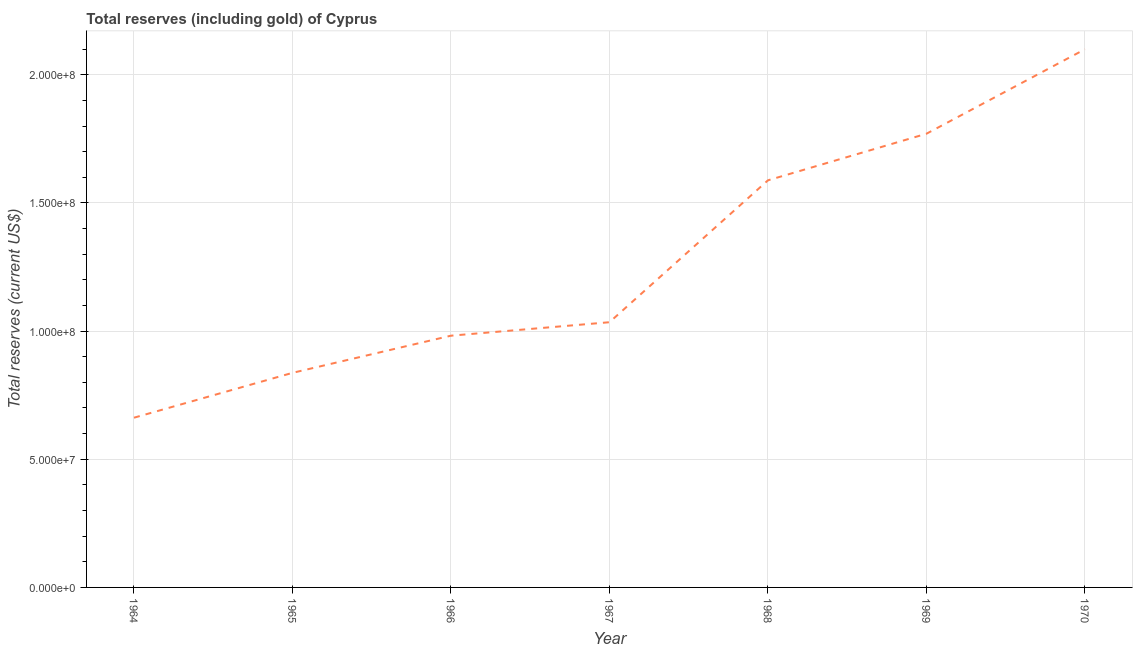What is the total reserves (including gold) in 1969?
Give a very brief answer. 1.77e+08. Across all years, what is the maximum total reserves (including gold)?
Your answer should be very brief. 2.10e+08. Across all years, what is the minimum total reserves (including gold)?
Give a very brief answer. 6.62e+07. In which year was the total reserves (including gold) minimum?
Your answer should be very brief. 1964. What is the sum of the total reserves (including gold)?
Make the answer very short. 8.97e+08. What is the difference between the total reserves (including gold) in 1966 and 1970?
Your answer should be compact. -1.12e+08. What is the average total reserves (including gold) per year?
Ensure brevity in your answer.  1.28e+08. What is the median total reserves (including gold)?
Your answer should be very brief. 1.03e+08. In how many years, is the total reserves (including gold) greater than 40000000 US$?
Your answer should be very brief. 7. What is the ratio of the total reserves (including gold) in 1966 to that in 1970?
Offer a terse response. 0.47. What is the difference between the highest and the second highest total reserves (including gold)?
Ensure brevity in your answer.  3.30e+07. What is the difference between the highest and the lowest total reserves (including gold)?
Your answer should be very brief. 1.44e+08. In how many years, is the total reserves (including gold) greater than the average total reserves (including gold) taken over all years?
Your response must be concise. 3. Does the total reserves (including gold) monotonically increase over the years?
Your response must be concise. Yes. How many lines are there?
Your answer should be very brief. 1. How many years are there in the graph?
Your response must be concise. 7. Are the values on the major ticks of Y-axis written in scientific E-notation?
Provide a succinct answer. Yes. What is the title of the graph?
Provide a succinct answer. Total reserves (including gold) of Cyprus. What is the label or title of the X-axis?
Your response must be concise. Year. What is the label or title of the Y-axis?
Provide a short and direct response. Total reserves (current US$). What is the Total reserves (current US$) in 1964?
Provide a succinct answer. 6.62e+07. What is the Total reserves (current US$) in 1965?
Ensure brevity in your answer.  8.37e+07. What is the Total reserves (current US$) of 1966?
Give a very brief answer. 9.82e+07. What is the Total reserves (current US$) in 1967?
Offer a terse response. 1.03e+08. What is the Total reserves (current US$) in 1968?
Your answer should be compact. 1.59e+08. What is the Total reserves (current US$) of 1969?
Offer a very short reply. 1.77e+08. What is the Total reserves (current US$) of 1970?
Your answer should be very brief. 2.10e+08. What is the difference between the Total reserves (current US$) in 1964 and 1965?
Provide a succinct answer. -1.75e+07. What is the difference between the Total reserves (current US$) in 1964 and 1966?
Offer a very short reply. -3.20e+07. What is the difference between the Total reserves (current US$) in 1964 and 1967?
Your answer should be compact. -3.72e+07. What is the difference between the Total reserves (current US$) in 1964 and 1968?
Give a very brief answer. -9.26e+07. What is the difference between the Total reserves (current US$) in 1964 and 1969?
Give a very brief answer. -1.11e+08. What is the difference between the Total reserves (current US$) in 1964 and 1970?
Give a very brief answer. -1.44e+08. What is the difference between the Total reserves (current US$) in 1965 and 1966?
Offer a terse response. -1.45e+07. What is the difference between the Total reserves (current US$) in 1965 and 1967?
Provide a succinct answer. -1.97e+07. What is the difference between the Total reserves (current US$) in 1965 and 1968?
Make the answer very short. -7.51e+07. What is the difference between the Total reserves (current US$) in 1965 and 1969?
Give a very brief answer. -9.33e+07. What is the difference between the Total reserves (current US$) in 1965 and 1970?
Give a very brief answer. -1.26e+08. What is the difference between the Total reserves (current US$) in 1966 and 1967?
Ensure brevity in your answer.  -5.25e+06. What is the difference between the Total reserves (current US$) in 1966 and 1968?
Your answer should be very brief. -6.06e+07. What is the difference between the Total reserves (current US$) in 1966 and 1969?
Offer a terse response. -7.88e+07. What is the difference between the Total reserves (current US$) in 1966 and 1970?
Provide a short and direct response. -1.12e+08. What is the difference between the Total reserves (current US$) in 1967 and 1968?
Give a very brief answer. -5.54e+07. What is the difference between the Total reserves (current US$) in 1967 and 1969?
Provide a succinct answer. -7.35e+07. What is the difference between the Total reserves (current US$) in 1967 and 1970?
Your answer should be compact. -1.06e+08. What is the difference between the Total reserves (current US$) in 1968 and 1969?
Your response must be concise. -1.82e+07. What is the difference between the Total reserves (current US$) in 1968 and 1970?
Provide a short and direct response. -5.11e+07. What is the difference between the Total reserves (current US$) in 1969 and 1970?
Your answer should be compact. -3.30e+07. What is the ratio of the Total reserves (current US$) in 1964 to that in 1965?
Ensure brevity in your answer.  0.79. What is the ratio of the Total reserves (current US$) in 1964 to that in 1966?
Ensure brevity in your answer.  0.67. What is the ratio of the Total reserves (current US$) in 1964 to that in 1967?
Make the answer very short. 0.64. What is the ratio of the Total reserves (current US$) in 1964 to that in 1968?
Offer a very short reply. 0.42. What is the ratio of the Total reserves (current US$) in 1964 to that in 1969?
Your answer should be very brief. 0.37. What is the ratio of the Total reserves (current US$) in 1964 to that in 1970?
Provide a short and direct response. 0.32. What is the ratio of the Total reserves (current US$) in 1965 to that in 1966?
Ensure brevity in your answer.  0.85. What is the ratio of the Total reserves (current US$) in 1965 to that in 1967?
Offer a very short reply. 0.81. What is the ratio of the Total reserves (current US$) in 1965 to that in 1968?
Offer a terse response. 0.53. What is the ratio of the Total reserves (current US$) in 1965 to that in 1969?
Ensure brevity in your answer.  0.47. What is the ratio of the Total reserves (current US$) in 1965 to that in 1970?
Make the answer very short. 0.4. What is the ratio of the Total reserves (current US$) in 1966 to that in 1967?
Ensure brevity in your answer.  0.95. What is the ratio of the Total reserves (current US$) in 1966 to that in 1968?
Make the answer very short. 0.62. What is the ratio of the Total reserves (current US$) in 1966 to that in 1969?
Provide a succinct answer. 0.56. What is the ratio of the Total reserves (current US$) in 1966 to that in 1970?
Provide a succinct answer. 0.47. What is the ratio of the Total reserves (current US$) in 1967 to that in 1968?
Keep it short and to the point. 0.65. What is the ratio of the Total reserves (current US$) in 1967 to that in 1969?
Make the answer very short. 0.58. What is the ratio of the Total reserves (current US$) in 1967 to that in 1970?
Offer a very short reply. 0.49. What is the ratio of the Total reserves (current US$) in 1968 to that in 1969?
Provide a succinct answer. 0.9. What is the ratio of the Total reserves (current US$) in 1968 to that in 1970?
Make the answer very short. 0.76. What is the ratio of the Total reserves (current US$) in 1969 to that in 1970?
Your response must be concise. 0.84. 